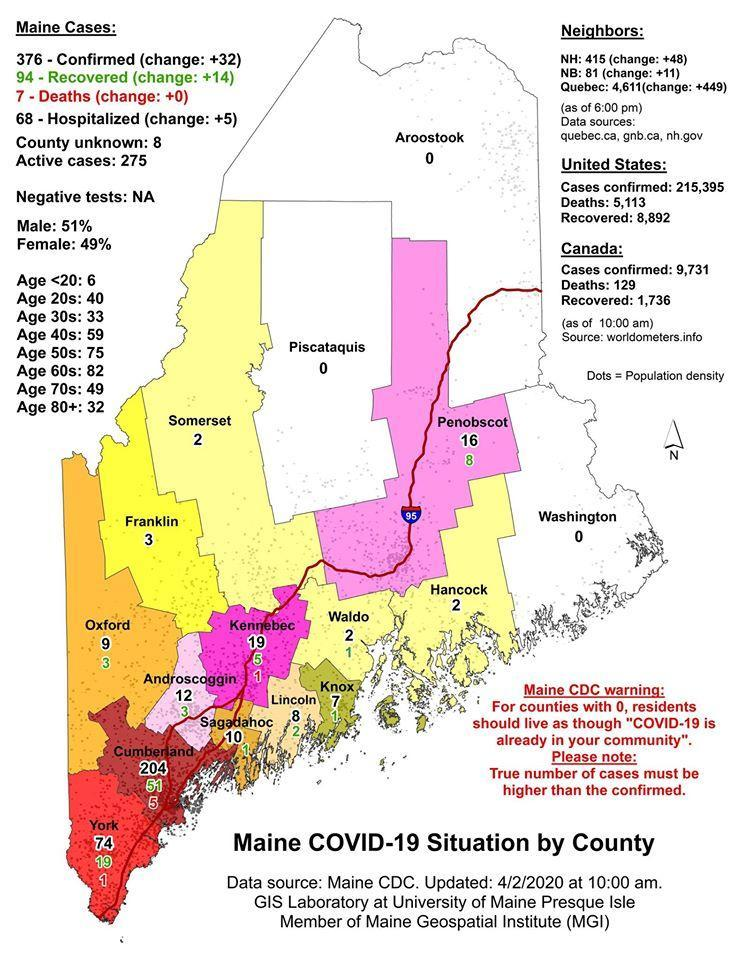What is the number of confirmed cases of COVID-19 reported in York county as of 4/2/2020?
Answer the question with a short phrase. 74 Which county in Maine has reported the highest number of confirmed COVID-19 cases as of 4/2/2020? Cumberland How many Covid-19 deaths were reported in Kennebec county as of 4/2/2020? 1 Which county in Maine has reported the highest number of COVID-19 deaths as of 4/2/2020? Cumberland Which county in Maine has no confirmed COVID-19 cases other than the Washington as of 4/2/2020? Aroostook, Piscataquis Which county in Maine has reported the second highest number of confirmed COVID-19 cases as of 4/2/2020? York How many Covid-19 deaths were reported in Cumberland as of 4/2/2020? 5 How many Covid-19 deaths were reported in the Maine state of U.S. as of 4/2/2020? 7 What is the total number of confirmed COVID-19 cases reported in the Maine state of U.S. as of 4/2/2020? 376 How many recoveries of COVID-19 cases were reported in Oxford as of 4/2/2020? 3 